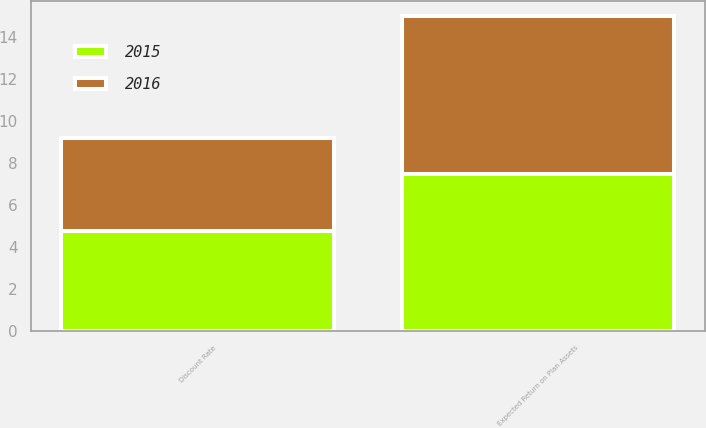<chart> <loc_0><loc_0><loc_500><loc_500><stacked_bar_chart><ecel><fcel>Discount Rate<fcel>Expected Return on Plan Assets<nl><fcel>2016<fcel>4.4<fcel>7.5<nl><fcel>2015<fcel>4.8<fcel>7.5<nl></chart> 